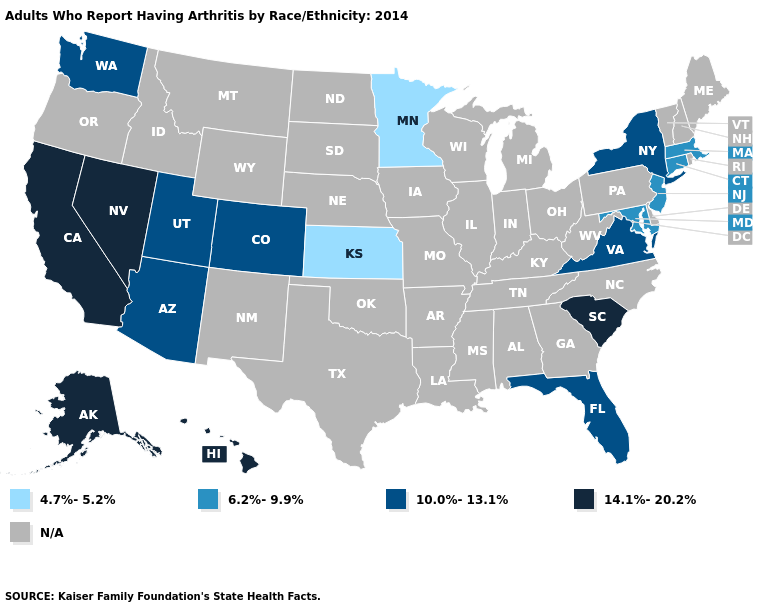How many symbols are there in the legend?
Be succinct. 5. What is the value of Idaho?
Give a very brief answer. N/A. What is the lowest value in the West?
Keep it brief. 10.0%-13.1%. Name the states that have a value in the range 4.7%-5.2%?
Concise answer only. Kansas, Minnesota. Name the states that have a value in the range 6.2%-9.9%?
Answer briefly. Connecticut, Maryland, Massachusetts, New Jersey. Name the states that have a value in the range 10.0%-13.1%?
Give a very brief answer. Arizona, Colorado, Florida, New York, Utah, Virginia, Washington. Name the states that have a value in the range 6.2%-9.9%?
Write a very short answer. Connecticut, Maryland, Massachusetts, New Jersey. What is the value of Tennessee?
Give a very brief answer. N/A. What is the value of Nebraska?
Keep it brief. N/A. What is the value of Indiana?
Write a very short answer. N/A. Which states have the lowest value in the USA?
Give a very brief answer. Kansas, Minnesota. What is the value of South Dakota?
Answer briefly. N/A. Does the map have missing data?
Keep it brief. Yes. Name the states that have a value in the range 14.1%-20.2%?
Answer briefly. Alaska, California, Hawaii, Nevada, South Carolina. 